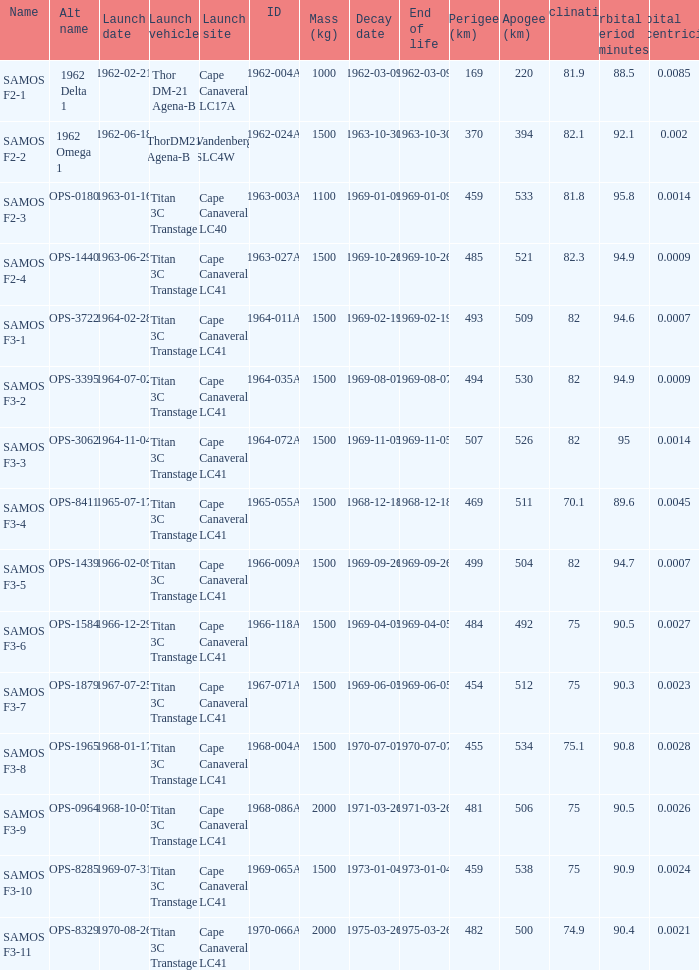How many alt names does 1964-011a have? 1.0. 